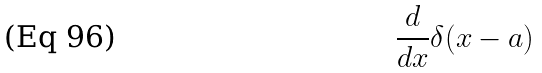<formula> <loc_0><loc_0><loc_500><loc_500>\frac { d } { d x } \delta ( x - a )</formula> 